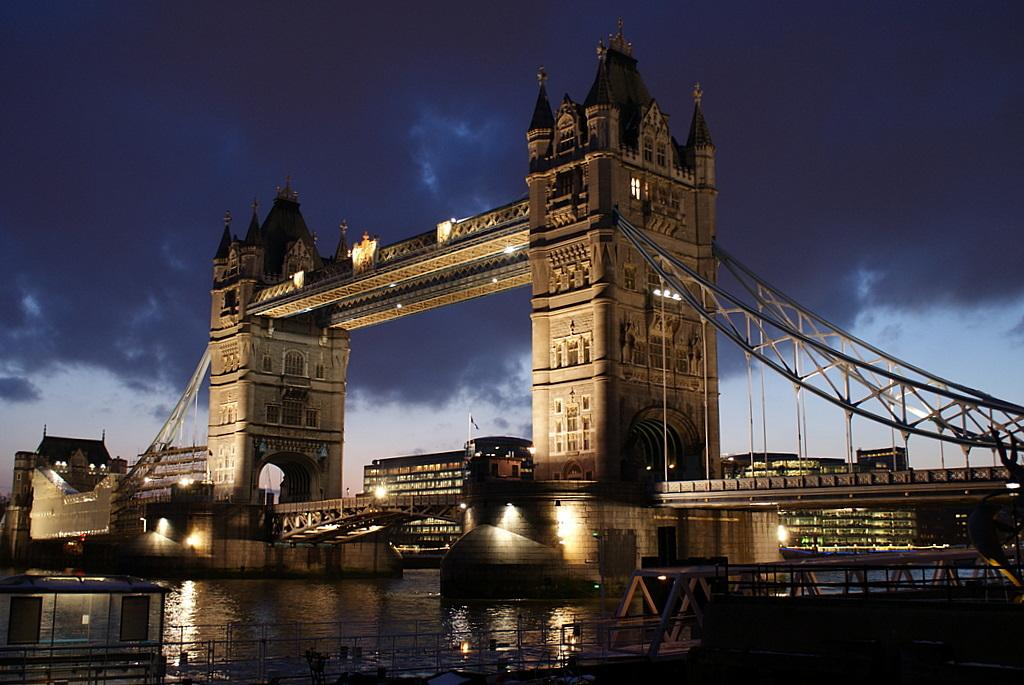What is the main structure in the image? There is a bridge in the image. What can be seen behind the bridge? Buildings are visible behind the bridge. What is the condition of the sky in the image? Clouds are present in the sky at the top of the image. What is visible at the bottom of the image? Water is visible at the bottom of the image. How many bars of soap are floating in the water beneath the bridge? There are no bars of soap present in the image; it only features a bridge, buildings, clouds, and water. 